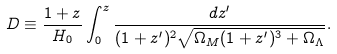Convert formula to latex. <formula><loc_0><loc_0><loc_500><loc_500>D \equiv \frac { 1 + z } { H _ { 0 } } \int ^ { z } _ { 0 } \frac { d z ^ { \prime } } { ( 1 + z ^ { \prime } ) ^ { 2 } \sqrt { \Omega _ { M } ( 1 + z ^ { \prime } ) ^ { 3 } + \Omega _ { \Lambda } } } .</formula> 